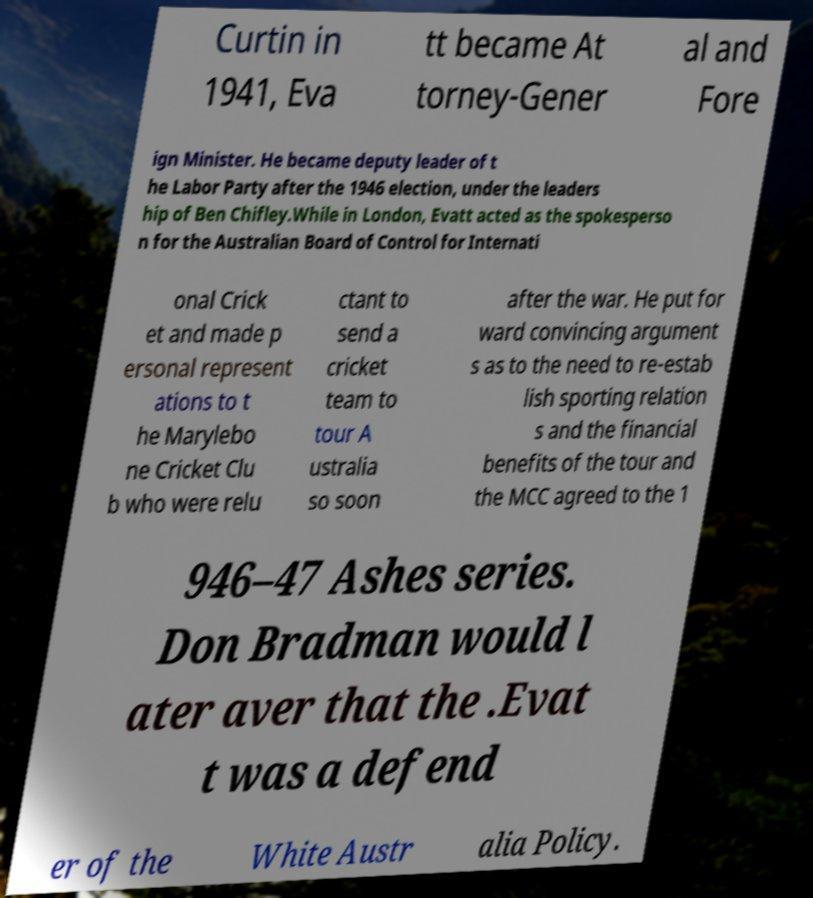I need the written content from this picture converted into text. Can you do that? Curtin in 1941, Eva tt became At torney-Gener al and Fore ign Minister. He became deputy leader of t he Labor Party after the 1946 election, under the leaders hip of Ben Chifley.While in London, Evatt acted as the spokesperso n for the Australian Board of Control for Internati onal Crick et and made p ersonal represent ations to t he Marylebo ne Cricket Clu b who were relu ctant to send a cricket team to tour A ustralia so soon after the war. He put for ward convincing argument s as to the need to re-estab lish sporting relation s and the financial benefits of the tour and the MCC agreed to the 1 946–47 Ashes series. Don Bradman would l ater aver that the .Evat t was a defend er of the White Austr alia Policy. 